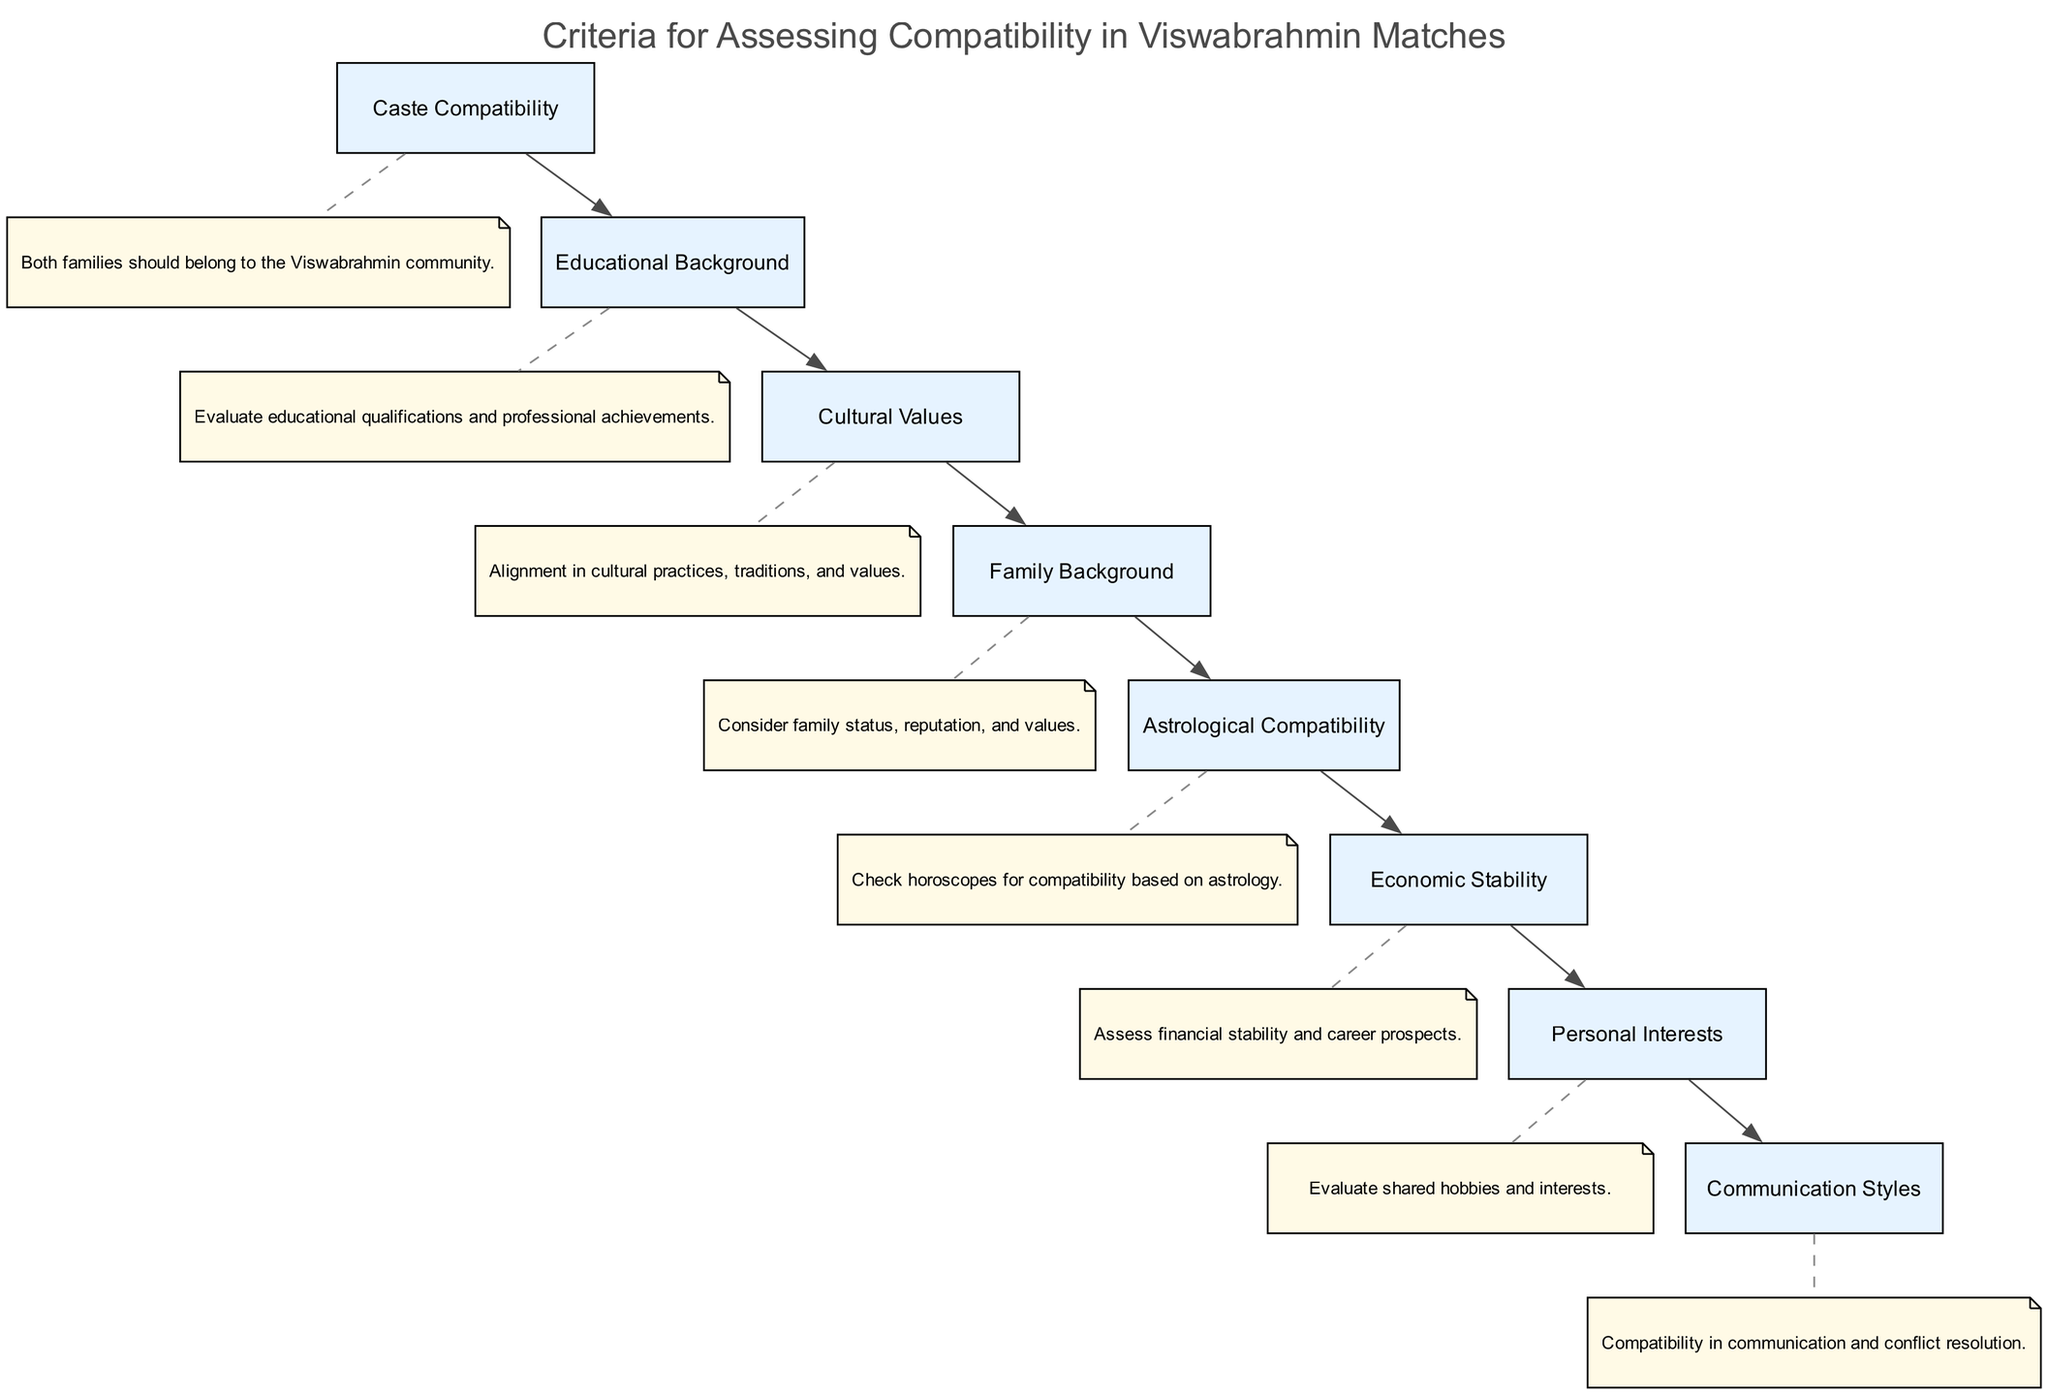What is the first criterion listed in the diagram? The first criterion in the flow chart is identified by its position at the top. It is labeled as "Caste Compatibility."
Answer: Caste Compatibility How many criteria are presented in the diagram? By counting the nodes representing criteria in the flow chart, there are a total of eight criteria shown.
Answer: 8 What is the last criterion mentioned in the flow chart? The last criterion is located at the end of the flow, and it is labeled as "Communication Styles."
Answer: Communication Styles Which criterion emphasizes financial aspects? The criterion that focuses on financial considerations is "Economic Stability." It is explicitly indicated in the flow chart.
Answer: Economic Stability What is the relationship between "Cultural Values" and "Family Background"? "Cultural Values" and "Family Background" are two separate criteria, but they are connected in the flow chart indicating a relationship. "Cultural Values" leads to "Family Background" in the sequence of criteria.
Answer: They are connected Which criterion requires the evaluation of horoscopes? The criterion that involves checking horoscopes for compatibility is named "Astrological Compatibility," as noted in the flow chart.
Answer: Astrological Compatibility How many connections (edges) are there between the criteria? The number of connections between the eight criteria can be determined by counting the flow lines connecting each consecutive criterion, which totals seven edges.
Answer: 7 What criterion comes after "Educational Background"? Following "Educational Background" in the flowchart is "Cultural Values," as it directly flows from the preceding criterion.
Answer: Cultural Values Which criterion deals with hobbies and interests? The criterion that assesses shared hobbies and interests is called "Personal Interests," which is explicitly listed in the diagram.
Answer: Personal Interests 